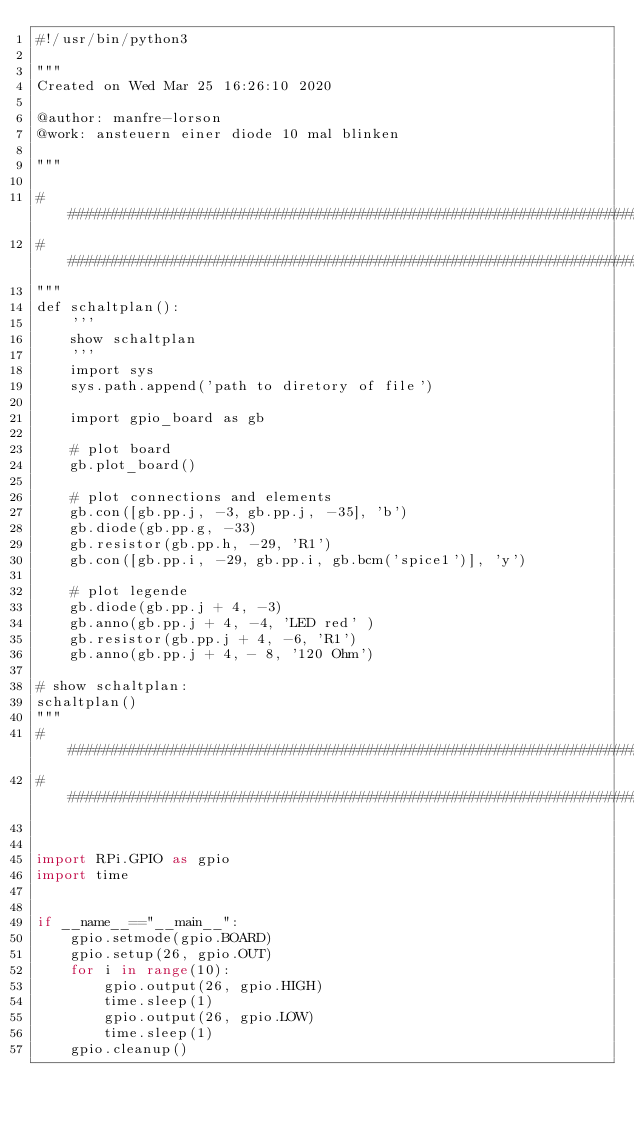Convert code to text. <code><loc_0><loc_0><loc_500><loc_500><_Python_>#!/usr/bin/python3

"""
Created on Wed Mar 25 16:26:10 2020

@author: manfre-lorson
@work: ansteuern einer diode 10 mal blinken

"""

##########################################################################
##########################################################################
"""
def schaltplan():
    '''
    show schaltplan
    '''
    import sys
    sys.path.append('path to diretory of file')
    
    import gpio_board as gb
    
    # plot board
    gb.plot_board()
    
    # plot connections and elements
    gb.con([gb.pp.j, -3, gb.pp.j, -35], 'b')
    gb.diode(gb.pp.g, -33)
    gb.resistor(gb.pp.h, -29, 'R1')
    gb.con([gb.pp.i, -29, gb.pp.i, gb.bcm('spice1')], 'y')
    
    # plot legende
    gb.diode(gb.pp.j + 4, -3)
    gb.anno(gb.pp.j + 4, -4, 'LED red' )
    gb.resistor(gb.pp.j + 4, -6, 'R1')
    gb.anno(gb.pp.j + 4, - 8, '120 Ohm')

# show schaltplan:
schaltplan()
"""
##########################################################################
##########################################################################


import RPi.GPIO as gpio
import time


if __name__=="__main__":
    gpio.setmode(gpio.BOARD)
    gpio.setup(26, gpio.OUT)
    for i in range(10):
        gpio.output(26, gpio.HIGH)
        time.sleep(1)
        gpio.output(26, gpio.LOW)
        time.sleep(1)
    gpio.cleanup()
    
</code> 